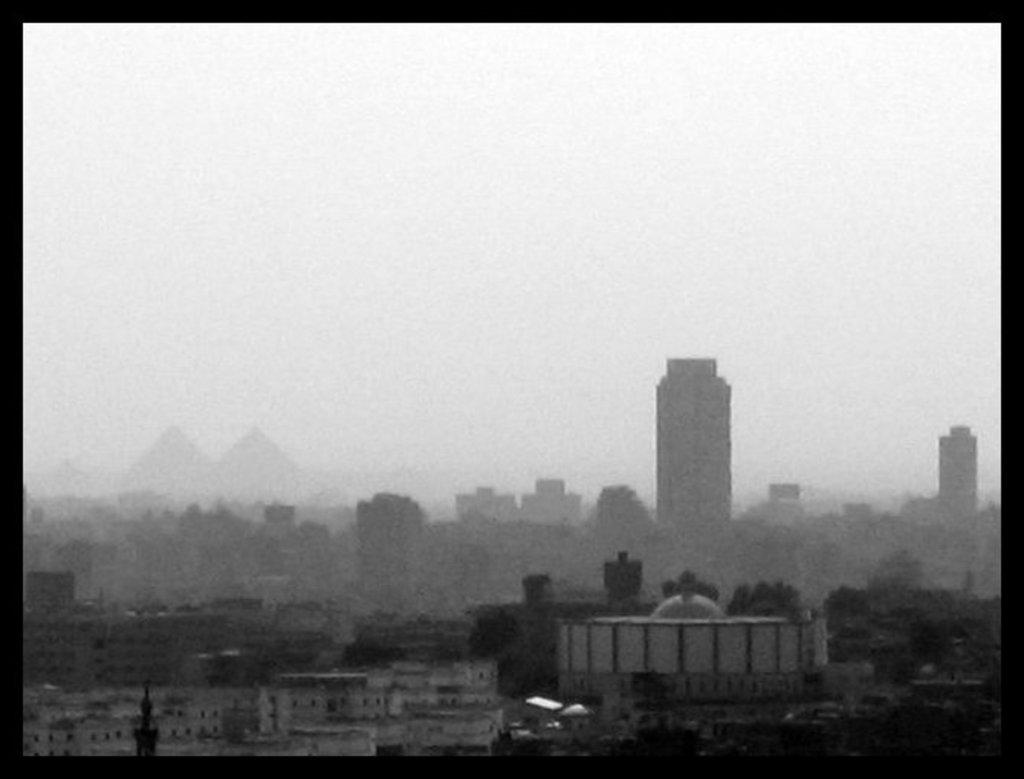What is the color scheme of the image? The image is black and white. What type of structures can be seen in the image? There are buildings in the image. What type of vegetation is present in the image? There are trees in the image. What part of the natural environment is visible in the image? The sky is visible in the image. What type of border is present in the image? There are black color borders in the image. What type of humor can be seen in the image? There is no humor present in the image; it is a black and white depiction of buildings, trees, and the sky. How many crows are visible in the image? There are no crows present in the image. 